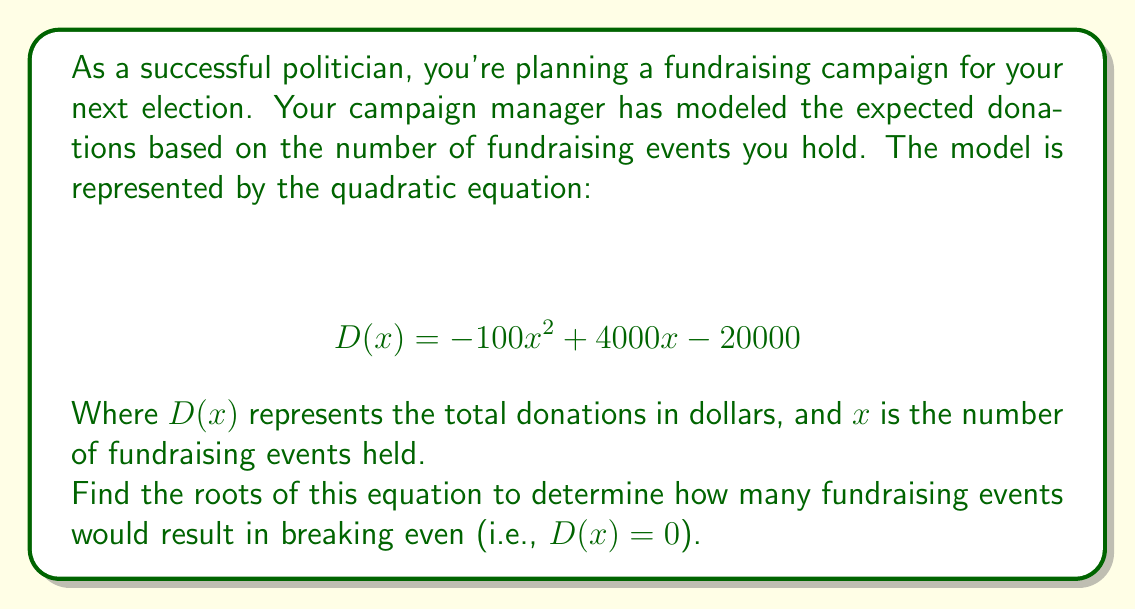Solve this math problem. To find the roots of the quadratic equation, we need to solve:

$$ -100x^2 + 4000x - 20000 = 0 $$

We can use the quadratic formula: $x = \frac{-b \pm \sqrt{b^2 - 4ac}}{2a}$

Where $a = -100$, $b = 4000$, and $c = -20000$

Step 1: Calculate the discriminant:
$$ b^2 - 4ac = 4000^2 - 4(-100)(-20000) = 16,000,000 - 8,000,000 = 8,000,000 $$

Step 2: Apply the quadratic formula:

$$ x = \frac{-4000 \pm \sqrt{8,000,000}}{2(-100)} $$

$$ x = \frac{-4000 \pm 2828.43}{-200} $$

Step 3: Simplify:

$$ x_1 = \frac{-4000 + 2828.43}{-200} = \frac{-1171.57}{-200} \approx 5.86 $$

$$ x_2 = \frac{-4000 - 2828.43}{-200} = \frac{-6828.43}{-200} \approx 34.14 $$

The roots are approximately 5.86 and 34.14 fundraising events.
Answer: The roots of the equation are approximately 5.86 and 34.14 fundraising events. 